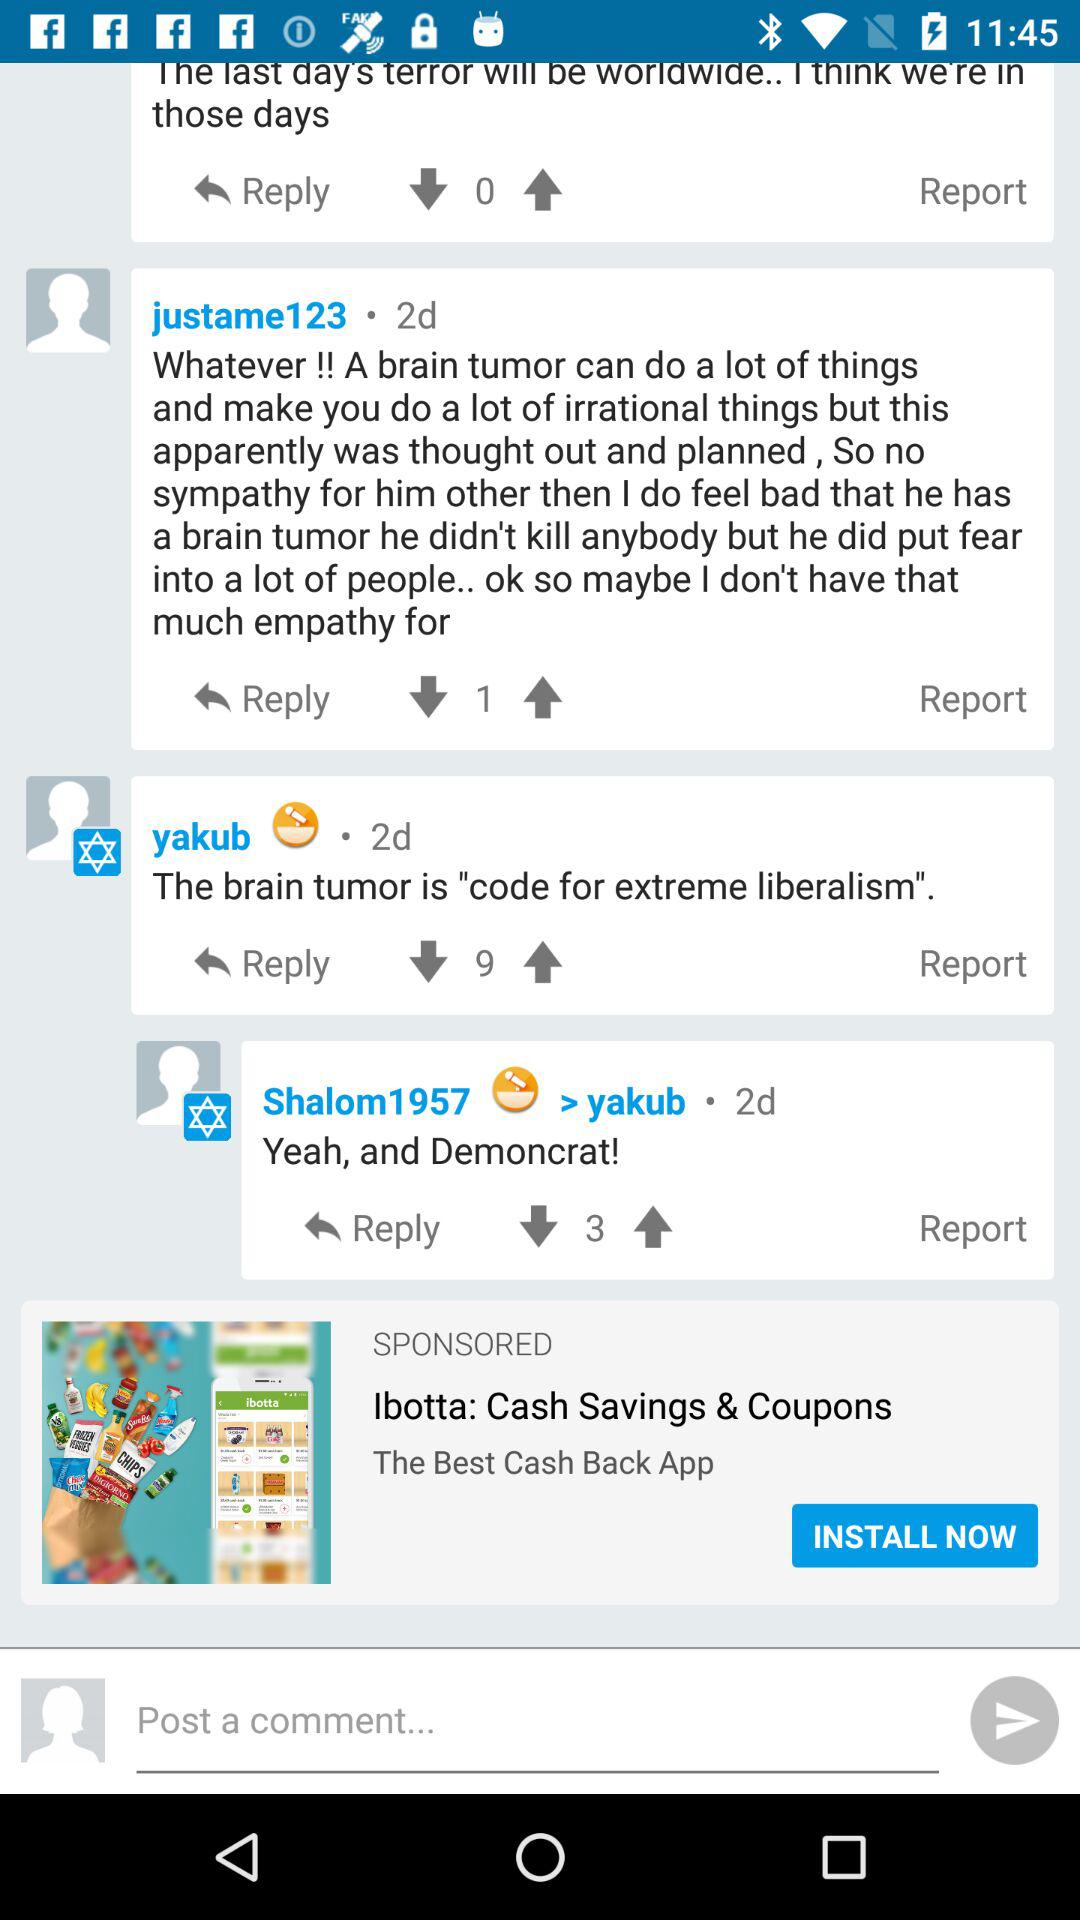How can we log in? You can log in with "Facebook". 